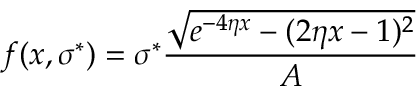<formula> <loc_0><loc_0><loc_500><loc_500>f ( x , \sigma ^ { * } ) = \sigma ^ { * } \frac { \sqrt { e ^ { - 4 \eta x } - ( 2 \eta x - 1 ) ^ { 2 } } } { A }</formula> 